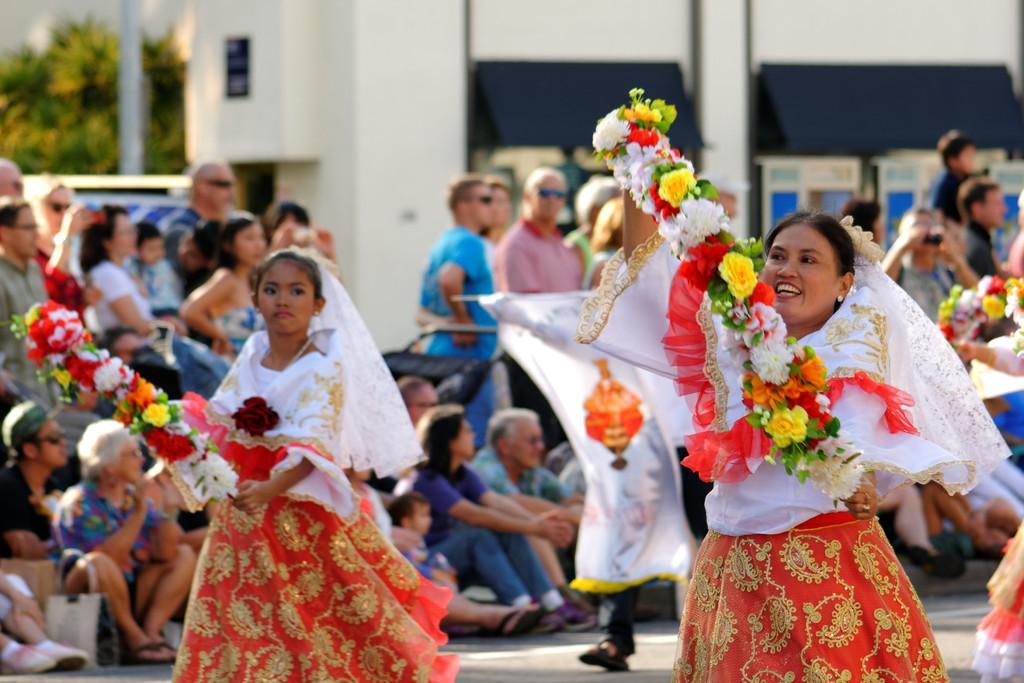Can you describe this image briefly? In the center of the image we can see a few people are standing and they are holding flower garlands. And they are in the same colorful costumes. And the middle person is smiling. In the background there is a building, trees, one vehicle, one banner, few people are standing, few people are sitting and a few other objects. 